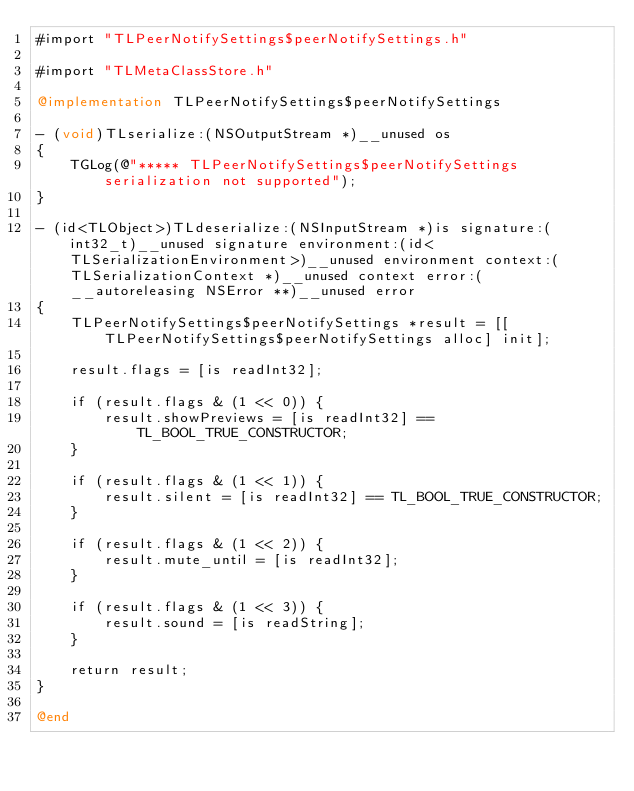Convert code to text. <code><loc_0><loc_0><loc_500><loc_500><_ObjectiveC_>#import "TLPeerNotifySettings$peerNotifySettings.h"

#import "TLMetaClassStore.h"

@implementation TLPeerNotifySettings$peerNotifySettings

- (void)TLserialize:(NSOutputStream *)__unused os
{
    TGLog(@"***** TLPeerNotifySettings$peerNotifySettings serialization not supported");
}

- (id<TLObject>)TLdeserialize:(NSInputStream *)is signature:(int32_t)__unused signature environment:(id<TLSerializationEnvironment>)__unused environment context:(TLSerializationContext *)__unused context error:(__autoreleasing NSError **)__unused error
{
    TLPeerNotifySettings$peerNotifySettings *result = [[TLPeerNotifySettings$peerNotifySettings alloc] init];
    
    result.flags = [is readInt32];
    
    if (result.flags & (1 << 0)) {
        result.showPreviews = [is readInt32] == TL_BOOL_TRUE_CONSTRUCTOR;
    }
    
    if (result.flags & (1 << 1)) {
        result.silent = [is readInt32] == TL_BOOL_TRUE_CONSTRUCTOR;
    }
    
    if (result.flags & (1 << 2)) {
        result.mute_until = [is readInt32];
    }
    
    if (result.flags & (1 << 3)) {
        result.sound = [is readString];
    }
    
    return result;
}

@end


</code> 